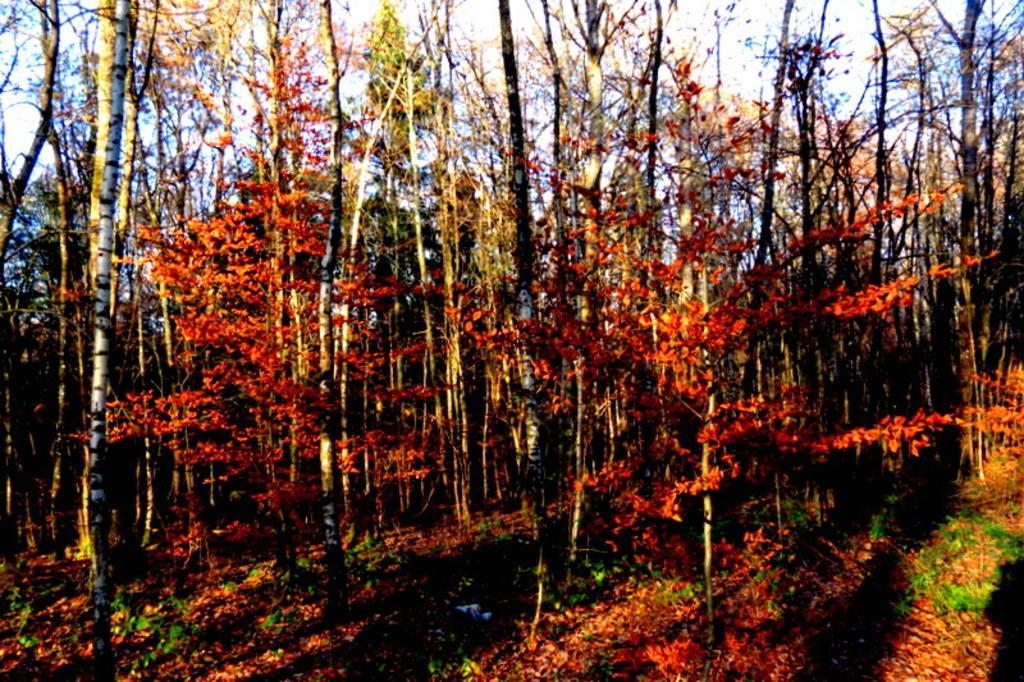How would you summarize this image in a sentence or two? In this image there is the sky, there are trees, there are trees truncated towards the top of the image, there are trees truncated towards the right of the image, there are trees truncated towards the left of the image, there is the grass. 